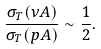Convert formula to latex. <formula><loc_0><loc_0><loc_500><loc_500>\frac { \sigma _ { T } ( \nu A ) } { \sigma _ { T } ( p A ) } \sim \frac { 1 } { 2 } .</formula> 